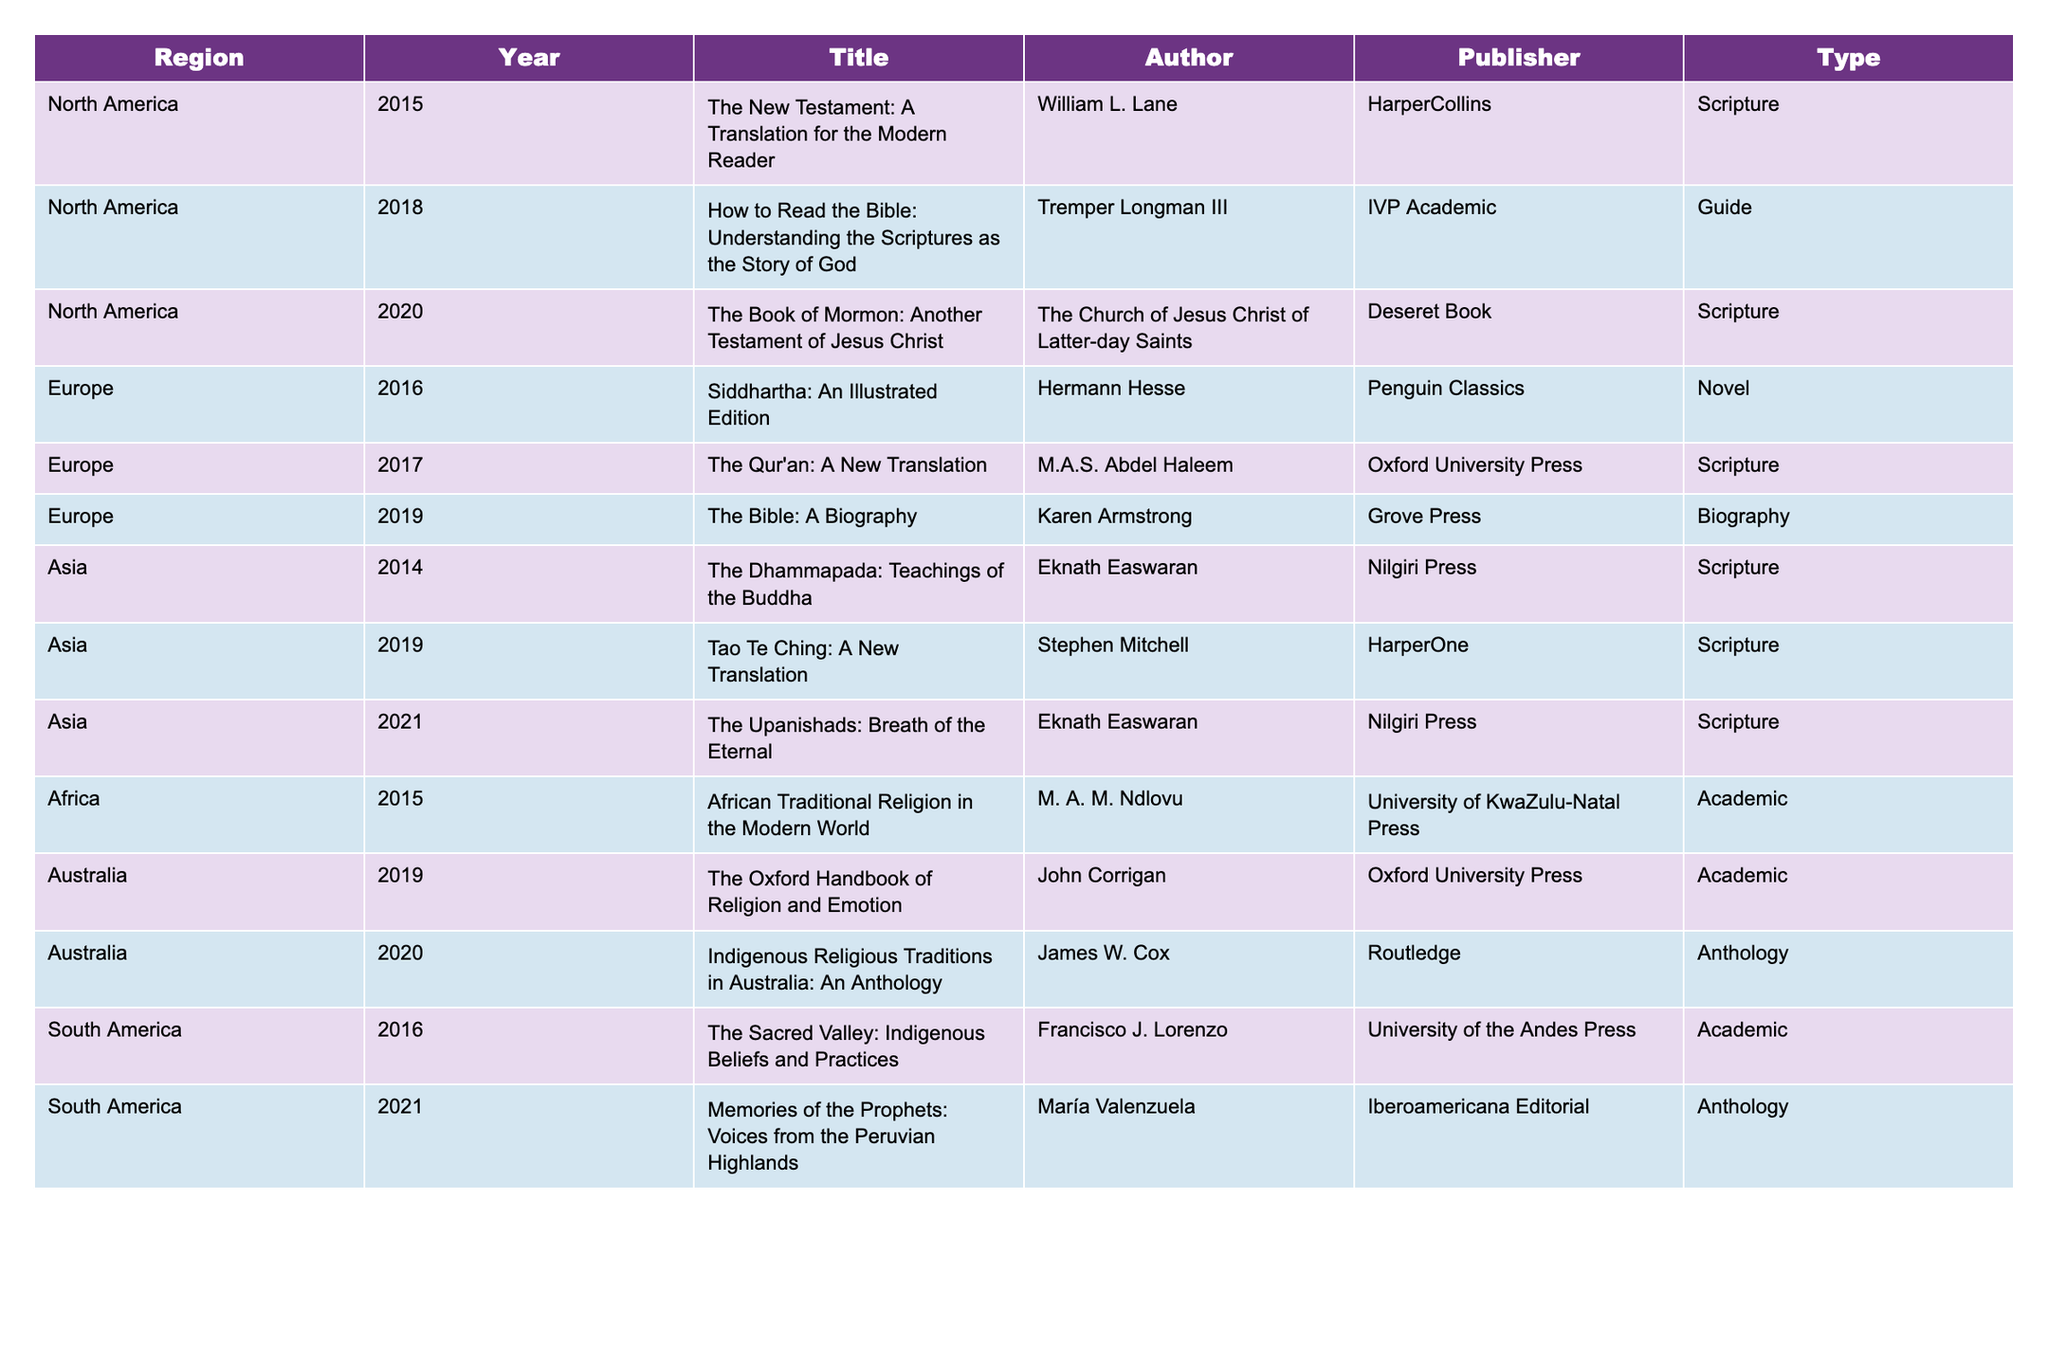What is the title of the book published in 2021? The table indicates that in 2021, "The Upanishads: Breath of the Eternal" was published.
Answer: The Upanishads: Breath of the Eternal Which author published a scripture in North America in 2020? According to the table, "The Book of Mormon: Another Testament of Jesus Christ" was published in North America in 2020 by The Church of Jesus Christ of Latter-day Saints.
Answer: The Church of Jesus Christ of Latter-day Saints How many books categorized as "Academic" were published in South America? The table shows that there were two "Academic" titles published in South America: "The Sacred Valley: Indigenous Beliefs and Practices" in 2016 and "Memories of the Prophets: Voices from the Peruvian Highlands" in 2021.
Answer: 2 Which region has the highest number of published religious texts listed? Counting the books in the table, North America has three titles, while Europe has three, Asia has three, Africa has one, South America has two, and Australia has two. Therefore, multiple regions have the highest number with three titles each.
Answer: North America, Europe, Asia Is there a book published in Africa in the last decade? The table includes "African Traditional Religion in the Modern World," published in 2015 in Africa, making it true that there is a book published in that region within the specified time frame.
Answer: Yes What is the median publication year for the books listed in the table? Listing the years: 2014, 2015, 2015, 2016, 2017, 2018, 2019, 2019, 2020, 2020, 2021, and 2021, and then ordering them gives us 2014, 2015, 2015, 2016, 2017, 2018, 2019, 2019, 2020, 2020, 2021, 2021. The median of these 12 numbers is the average of the 6th and 7th, which are 2018 and 2019, so (2018 + 2019) / 2 = 2018.5.
Answer: 2018.5 Which types of books did Eknath Easwaran write, and in which regions? The table indicates that Eknath Easwaran wrote two "Scripture" types: "The Dhammapada: Teachings of the Buddha" in Asia in 2014 and "The Upanishads: Breath of the Eternal" in Asia in 2021.
Answer: Scripture, Asia How many different publishers are represented in the table? By counting distinct publishers from the table entries, we find 10 unique publishers.
Answer: 10 